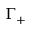<formula> <loc_0><loc_0><loc_500><loc_500>\Gamma _ { + }</formula> 